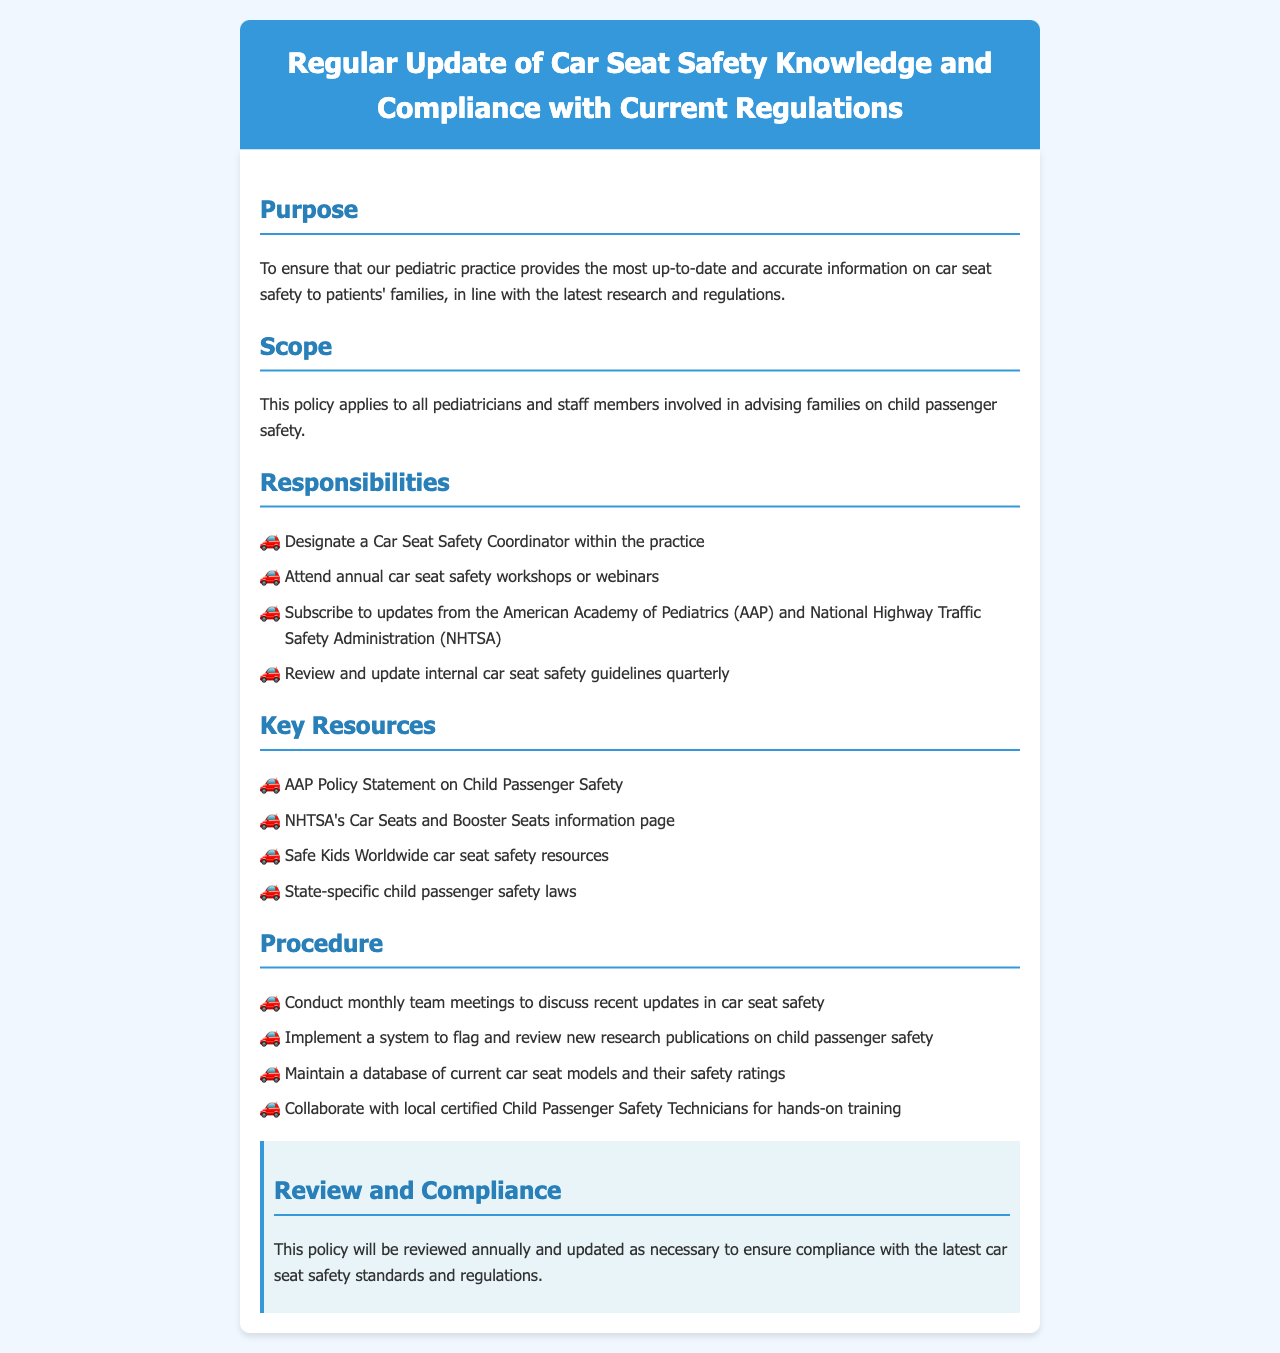What is the purpose of this policy? The purpose is to ensure that the pediatric practice provides the most up-to-date and accurate information on car seat safety to patients' families, in line with the latest research and regulations.
Answer: To ensure that our pediatric practice provides the most up-to-date and accurate information on car seat safety to patients' families, in line with the latest research and regulations Who is responsible for designating a Car Seat Safety Coordinator? This responsibility falls on all pediatricians and staff members involved in advising families on child passenger safety.
Answer: All pediatricians and staff members involved in advising families on child passenger safety How often should car seat safety guidelines be reviewed? The internal car seat safety guidelines should be reviewed quarterly.
Answer: Quarterly What is one key resource mentioned in the document? The document lists several key resources, one of which is the AAP Policy Statement on Child Passenger Safety.
Answer: AAP Policy Statement on Child Passenger Safety How frequently should team meetings be conducted according to the policy? Monthly team meetings should be conducted to discuss recent updates in car seat safety.
Answer: Monthly What is the review frequency for this policy? The policy will be reviewed annually and updated as necessary.
Answer: Annually What should be maintained as part of the procedure outlined? A database of current car seat models and their safety ratings should be maintained.
Answer: A database of current car seat models and their safety ratings Which organization provides updates that staff should subscribe to? Staff members should subscribe to updates from the American Academy of Pediatrics (AAP).
Answer: American Academy of Pediatrics (AAP) 